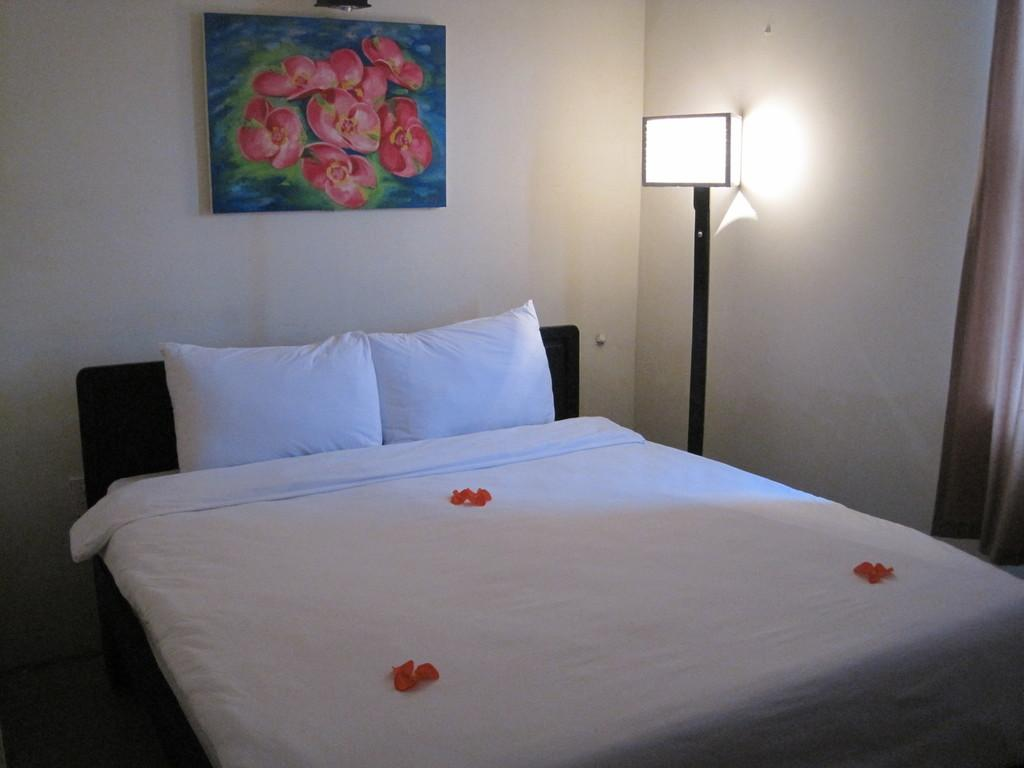What piece of furniture is the main subject of the image? There is a bed in the image. What accessories are on the bed? The bed has two pillows and a blanket. What can be seen in the background of the image? There is a photo frame and a lamp in the background of the image. What type of horn can be seen on the bed in the image? There is no horn present on the bed or in the image. 